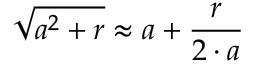Convert formula to latex. <formula><loc_0><loc_0><loc_500><loc_500>{ \sqrt { a ^ { 2 } + r } } \approx a + { \frac { r } { 2 \cdot a } }</formula> 